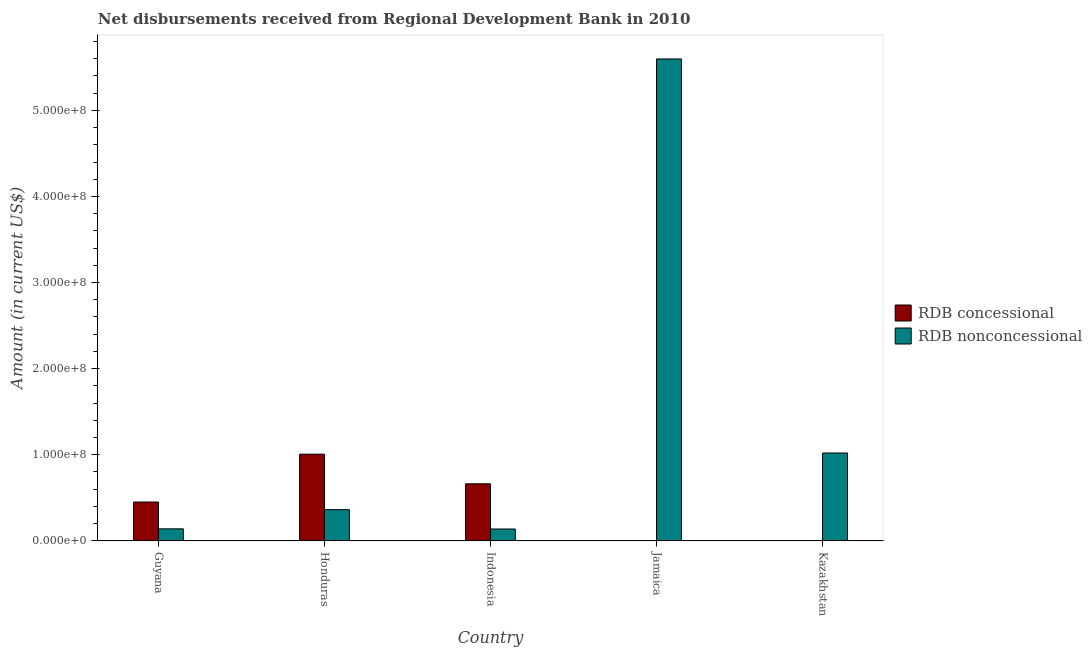How many bars are there on the 2nd tick from the right?
Provide a short and direct response. 1. What is the label of the 1st group of bars from the left?
Provide a succinct answer. Guyana. What is the net non concessional disbursements from rdb in Indonesia?
Keep it short and to the point. 1.36e+07. Across all countries, what is the maximum net non concessional disbursements from rdb?
Your answer should be compact. 5.60e+08. In which country was the net non concessional disbursements from rdb maximum?
Offer a very short reply. Jamaica. What is the total net concessional disbursements from rdb in the graph?
Keep it short and to the point. 2.12e+08. What is the difference between the net non concessional disbursements from rdb in Jamaica and that in Kazakhstan?
Your answer should be very brief. 4.58e+08. What is the difference between the net concessional disbursements from rdb in Kazakhstan and the net non concessional disbursements from rdb in Jamaica?
Your answer should be very brief. -5.60e+08. What is the average net concessional disbursements from rdb per country?
Keep it short and to the point. 4.23e+07. What is the difference between the net concessional disbursements from rdb and net non concessional disbursements from rdb in Indonesia?
Give a very brief answer. 5.25e+07. What is the ratio of the net non concessional disbursements from rdb in Guyana to that in Jamaica?
Give a very brief answer. 0.02. Is the net concessional disbursements from rdb in Honduras less than that in Indonesia?
Offer a very short reply. No. Is the difference between the net concessional disbursements from rdb in Guyana and Indonesia greater than the difference between the net non concessional disbursements from rdb in Guyana and Indonesia?
Your answer should be very brief. No. What is the difference between the highest and the second highest net concessional disbursements from rdb?
Your answer should be very brief. 3.44e+07. What is the difference between the highest and the lowest net concessional disbursements from rdb?
Offer a terse response. 1.01e+08. In how many countries, is the net concessional disbursements from rdb greater than the average net concessional disbursements from rdb taken over all countries?
Keep it short and to the point. 3. Is the sum of the net non concessional disbursements from rdb in Indonesia and Jamaica greater than the maximum net concessional disbursements from rdb across all countries?
Ensure brevity in your answer.  Yes. Are all the bars in the graph horizontal?
Your answer should be very brief. No. What is the difference between two consecutive major ticks on the Y-axis?
Provide a succinct answer. 1.00e+08. Are the values on the major ticks of Y-axis written in scientific E-notation?
Provide a succinct answer. Yes. Does the graph contain any zero values?
Keep it short and to the point. Yes. Where does the legend appear in the graph?
Give a very brief answer. Center right. How are the legend labels stacked?
Your answer should be very brief. Vertical. What is the title of the graph?
Give a very brief answer. Net disbursements received from Regional Development Bank in 2010. Does "Under-5(female)" appear as one of the legend labels in the graph?
Provide a succinct answer. No. What is the label or title of the Y-axis?
Provide a short and direct response. Amount (in current US$). What is the Amount (in current US$) in RDB concessional in Guyana?
Your answer should be compact. 4.50e+07. What is the Amount (in current US$) of RDB nonconcessional in Guyana?
Make the answer very short. 1.38e+07. What is the Amount (in current US$) in RDB concessional in Honduras?
Keep it short and to the point. 1.01e+08. What is the Amount (in current US$) of RDB nonconcessional in Honduras?
Ensure brevity in your answer.  3.61e+07. What is the Amount (in current US$) in RDB concessional in Indonesia?
Your answer should be compact. 6.61e+07. What is the Amount (in current US$) of RDB nonconcessional in Indonesia?
Your answer should be compact. 1.36e+07. What is the Amount (in current US$) of RDB concessional in Jamaica?
Your response must be concise. 0. What is the Amount (in current US$) of RDB nonconcessional in Jamaica?
Provide a short and direct response. 5.60e+08. What is the Amount (in current US$) in RDB concessional in Kazakhstan?
Provide a short and direct response. 0. What is the Amount (in current US$) of RDB nonconcessional in Kazakhstan?
Keep it short and to the point. 1.02e+08. Across all countries, what is the maximum Amount (in current US$) of RDB concessional?
Make the answer very short. 1.01e+08. Across all countries, what is the maximum Amount (in current US$) of RDB nonconcessional?
Your response must be concise. 5.60e+08. Across all countries, what is the minimum Amount (in current US$) in RDB nonconcessional?
Provide a succinct answer. 1.36e+07. What is the total Amount (in current US$) in RDB concessional in the graph?
Offer a very short reply. 2.12e+08. What is the total Amount (in current US$) in RDB nonconcessional in the graph?
Offer a very short reply. 7.25e+08. What is the difference between the Amount (in current US$) in RDB concessional in Guyana and that in Honduras?
Your response must be concise. -5.56e+07. What is the difference between the Amount (in current US$) in RDB nonconcessional in Guyana and that in Honduras?
Provide a short and direct response. -2.23e+07. What is the difference between the Amount (in current US$) in RDB concessional in Guyana and that in Indonesia?
Provide a succinct answer. -2.12e+07. What is the difference between the Amount (in current US$) in RDB nonconcessional in Guyana and that in Indonesia?
Offer a terse response. 2.15e+05. What is the difference between the Amount (in current US$) in RDB nonconcessional in Guyana and that in Jamaica?
Give a very brief answer. -5.46e+08. What is the difference between the Amount (in current US$) of RDB nonconcessional in Guyana and that in Kazakhstan?
Give a very brief answer. -8.81e+07. What is the difference between the Amount (in current US$) of RDB concessional in Honduras and that in Indonesia?
Provide a succinct answer. 3.44e+07. What is the difference between the Amount (in current US$) in RDB nonconcessional in Honduras and that in Indonesia?
Ensure brevity in your answer.  2.25e+07. What is the difference between the Amount (in current US$) in RDB nonconcessional in Honduras and that in Jamaica?
Give a very brief answer. -5.24e+08. What is the difference between the Amount (in current US$) of RDB nonconcessional in Honduras and that in Kazakhstan?
Your answer should be very brief. -6.58e+07. What is the difference between the Amount (in current US$) of RDB nonconcessional in Indonesia and that in Jamaica?
Keep it short and to the point. -5.46e+08. What is the difference between the Amount (in current US$) of RDB nonconcessional in Indonesia and that in Kazakhstan?
Your answer should be very brief. -8.83e+07. What is the difference between the Amount (in current US$) of RDB nonconcessional in Jamaica and that in Kazakhstan?
Your answer should be very brief. 4.58e+08. What is the difference between the Amount (in current US$) of RDB concessional in Guyana and the Amount (in current US$) of RDB nonconcessional in Honduras?
Ensure brevity in your answer.  8.88e+06. What is the difference between the Amount (in current US$) of RDB concessional in Guyana and the Amount (in current US$) of RDB nonconcessional in Indonesia?
Your answer should be compact. 3.14e+07. What is the difference between the Amount (in current US$) in RDB concessional in Guyana and the Amount (in current US$) in RDB nonconcessional in Jamaica?
Provide a short and direct response. -5.15e+08. What is the difference between the Amount (in current US$) of RDB concessional in Guyana and the Amount (in current US$) of RDB nonconcessional in Kazakhstan?
Provide a short and direct response. -5.70e+07. What is the difference between the Amount (in current US$) in RDB concessional in Honduras and the Amount (in current US$) in RDB nonconcessional in Indonesia?
Your answer should be very brief. 8.69e+07. What is the difference between the Amount (in current US$) of RDB concessional in Honduras and the Amount (in current US$) of RDB nonconcessional in Jamaica?
Give a very brief answer. -4.59e+08. What is the difference between the Amount (in current US$) in RDB concessional in Honduras and the Amount (in current US$) in RDB nonconcessional in Kazakhstan?
Your answer should be compact. -1.39e+06. What is the difference between the Amount (in current US$) in RDB concessional in Indonesia and the Amount (in current US$) in RDB nonconcessional in Jamaica?
Offer a very short reply. -4.94e+08. What is the difference between the Amount (in current US$) of RDB concessional in Indonesia and the Amount (in current US$) of RDB nonconcessional in Kazakhstan?
Make the answer very short. -3.58e+07. What is the average Amount (in current US$) in RDB concessional per country?
Give a very brief answer. 4.23e+07. What is the average Amount (in current US$) in RDB nonconcessional per country?
Ensure brevity in your answer.  1.45e+08. What is the difference between the Amount (in current US$) in RDB concessional and Amount (in current US$) in RDB nonconcessional in Guyana?
Provide a short and direct response. 3.12e+07. What is the difference between the Amount (in current US$) in RDB concessional and Amount (in current US$) in RDB nonconcessional in Honduras?
Give a very brief answer. 6.44e+07. What is the difference between the Amount (in current US$) of RDB concessional and Amount (in current US$) of RDB nonconcessional in Indonesia?
Offer a very short reply. 5.25e+07. What is the ratio of the Amount (in current US$) of RDB concessional in Guyana to that in Honduras?
Your answer should be very brief. 0.45. What is the ratio of the Amount (in current US$) of RDB nonconcessional in Guyana to that in Honduras?
Give a very brief answer. 0.38. What is the ratio of the Amount (in current US$) in RDB concessional in Guyana to that in Indonesia?
Give a very brief answer. 0.68. What is the ratio of the Amount (in current US$) in RDB nonconcessional in Guyana to that in Indonesia?
Ensure brevity in your answer.  1.02. What is the ratio of the Amount (in current US$) in RDB nonconcessional in Guyana to that in Jamaica?
Ensure brevity in your answer.  0.02. What is the ratio of the Amount (in current US$) of RDB nonconcessional in Guyana to that in Kazakhstan?
Your answer should be compact. 0.14. What is the ratio of the Amount (in current US$) in RDB concessional in Honduras to that in Indonesia?
Keep it short and to the point. 1.52. What is the ratio of the Amount (in current US$) of RDB nonconcessional in Honduras to that in Indonesia?
Ensure brevity in your answer.  2.65. What is the ratio of the Amount (in current US$) in RDB nonconcessional in Honduras to that in Jamaica?
Keep it short and to the point. 0.06. What is the ratio of the Amount (in current US$) in RDB nonconcessional in Honduras to that in Kazakhstan?
Keep it short and to the point. 0.35. What is the ratio of the Amount (in current US$) of RDB nonconcessional in Indonesia to that in Jamaica?
Your answer should be compact. 0.02. What is the ratio of the Amount (in current US$) of RDB nonconcessional in Indonesia to that in Kazakhstan?
Give a very brief answer. 0.13. What is the ratio of the Amount (in current US$) of RDB nonconcessional in Jamaica to that in Kazakhstan?
Your answer should be very brief. 5.49. What is the difference between the highest and the second highest Amount (in current US$) of RDB concessional?
Keep it short and to the point. 3.44e+07. What is the difference between the highest and the second highest Amount (in current US$) of RDB nonconcessional?
Your response must be concise. 4.58e+08. What is the difference between the highest and the lowest Amount (in current US$) of RDB concessional?
Offer a very short reply. 1.01e+08. What is the difference between the highest and the lowest Amount (in current US$) in RDB nonconcessional?
Your answer should be compact. 5.46e+08. 